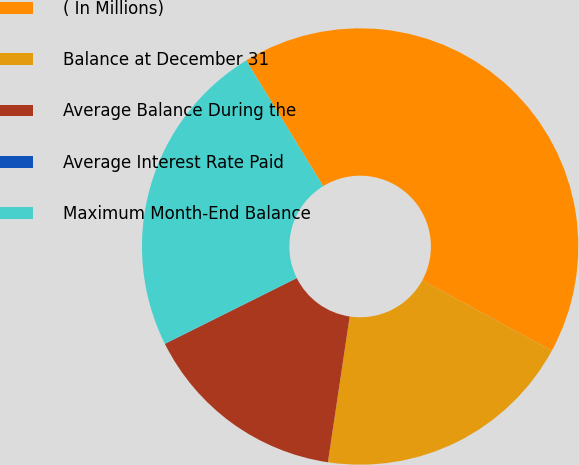Convert chart to OTSL. <chart><loc_0><loc_0><loc_500><loc_500><pie_chart><fcel>( In Millions)<fcel>Balance at December 31<fcel>Average Balance During the<fcel>Average Interest Rate Paid<fcel>Maximum Month-End Balance<nl><fcel>41.68%<fcel>19.43%<fcel>15.27%<fcel>0.02%<fcel>23.6%<nl></chart> 